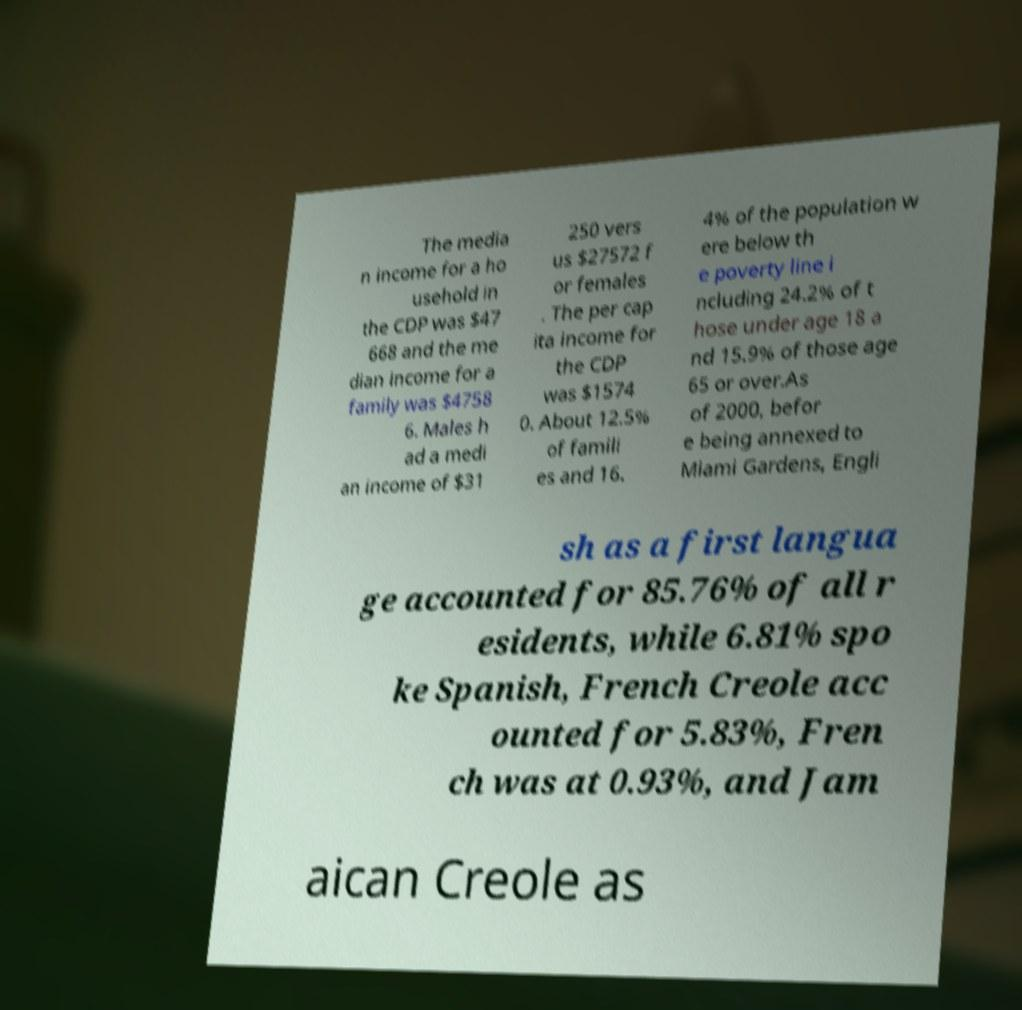Please read and relay the text visible in this image. What does it say? The media n income for a ho usehold in the CDP was $47 668 and the me dian income for a family was $4758 6. Males h ad a medi an income of $31 250 vers us $27572 f or females . The per cap ita income for the CDP was $1574 0. About 12.5% of famili es and 16. 4% of the population w ere below th e poverty line i ncluding 24.2% of t hose under age 18 a nd 15.9% of those age 65 or over.As of 2000, befor e being annexed to Miami Gardens, Engli sh as a first langua ge accounted for 85.76% of all r esidents, while 6.81% spo ke Spanish, French Creole acc ounted for 5.83%, Fren ch was at 0.93%, and Jam aican Creole as 